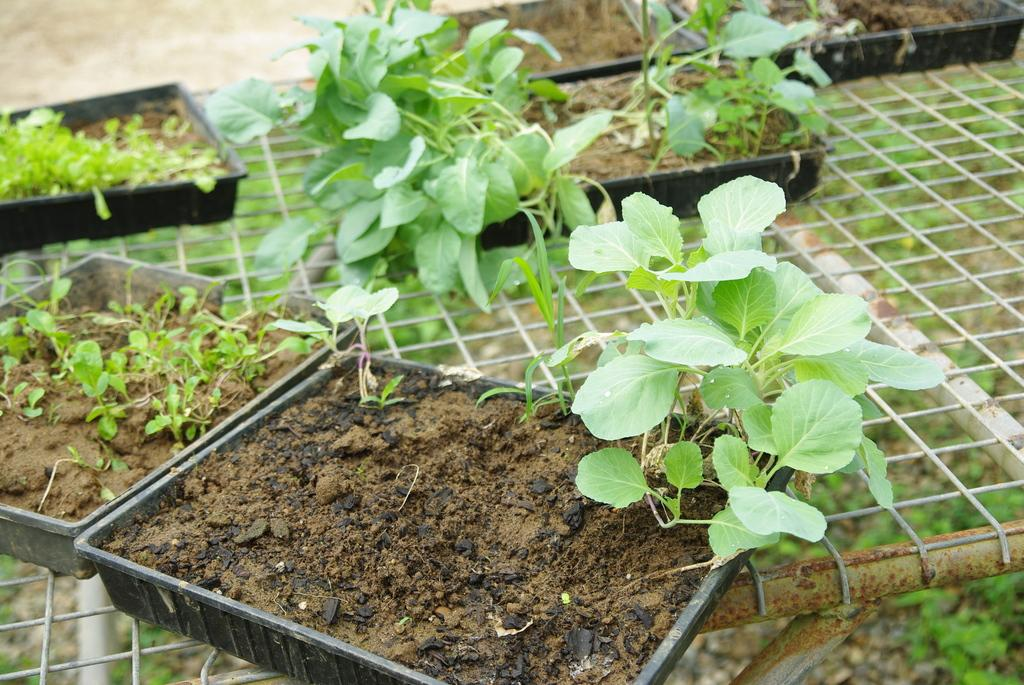What is the surface on which the plants are placed in the image? The plants are on mud in the image. What is the color of the trays that hold the mud? The trays are on black color in the image. How are the trays supported or elevated? The trays are on a net in the image. What can be seen in the background of the image? In the background, there are plants on the ground. Can you see a goat grazing among the plants in the image? No, there is no goat present in the image. 